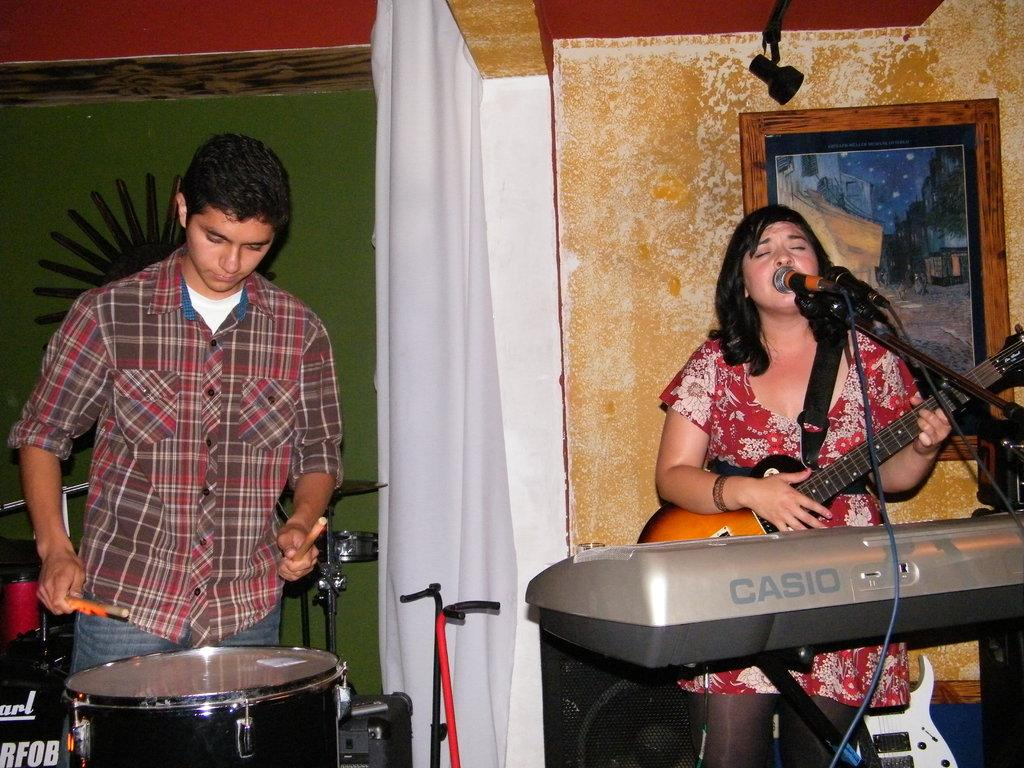What is the woman doing in the image? The woman is singing with a mic and playing drums. Who is beside the woman? There is a man beside the woman. What is the man doing in the image? The man is playing drums. What musical instrument is in front of them? There is a Casio keyboard in front of them. How many chickens are on the Casio keyboard in the image? There are no chickens present in the image, and the Casio keyboard is not mentioned as having any chickens on it. 